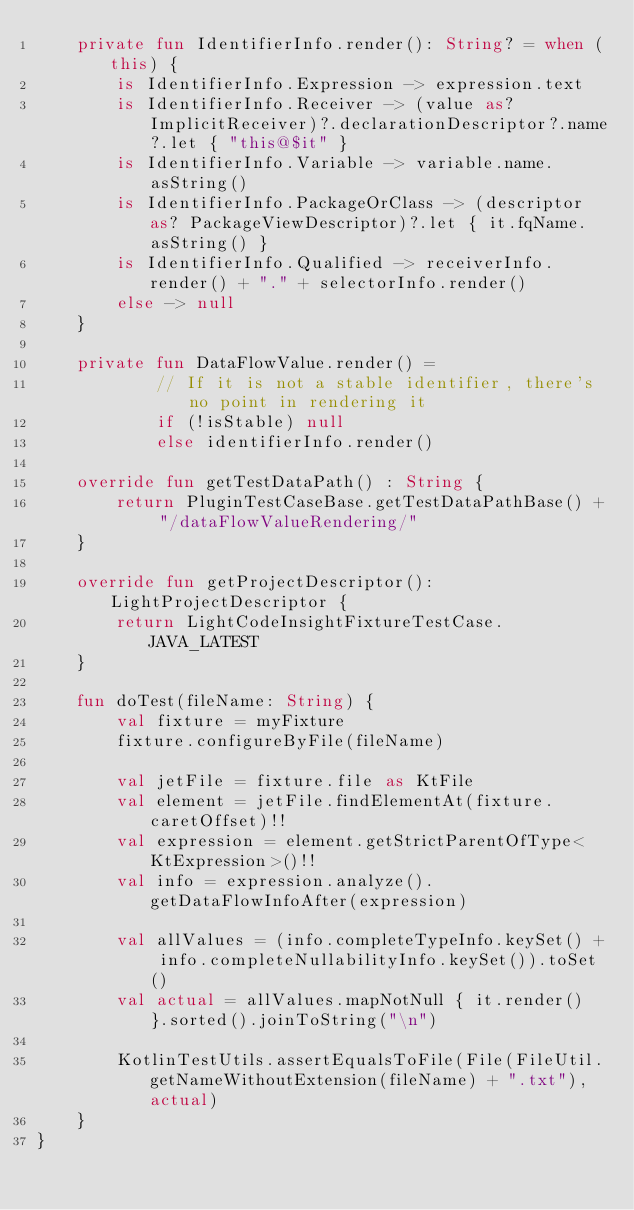Convert code to text. <code><loc_0><loc_0><loc_500><loc_500><_Kotlin_>    private fun IdentifierInfo.render(): String? = when (this) {
        is IdentifierInfo.Expression -> expression.text
        is IdentifierInfo.Receiver -> (value as? ImplicitReceiver)?.declarationDescriptor?.name?.let { "this@$it" }
        is IdentifierInfo.Variable -> variable.name.asString()
        is IdentifierInfo.PackageOrClass -> (descriptor as? PackageViewDescriptor)?.let { it.fqName.asString() }
        is IdentifierInfo.Qualified -> receiverInfo.render() + "." + selectorInfo.render()
        else -> null
    }

    private fun DataFlowValue.render() =
            // If it is not a stable identifier, there's no point in rendering it
            if (!isStable) null
            else identifierInfo.render()

    override fun getTestDataPath() : String {
        return PluginTestCaseBase.getTestDataPathBase() + "/dataFlowValueRendering/"
    }

    override fun getProjectDescriptor(): LightProjectDescriptor {
        return LightCodeInsightFixtureTestCase.JAVA_LATEST
    }

    fun doTest(fileName: String) {
        val fixture = myFixture
        fixture.configureByFile(fileName)

        val jetFile = fixture.file as KtFile
        val element = jetFile.findElementAt(fixture.caretOffset)!!
        val expression = element.getStrictParentOfType<KtExpression>()!!
        val info = expression.analyze().getDataFlowInfoAfter(expression)

        val allValues = (info.completeTypeInfo.keySet() + info.completeNullabilityInfo.keySet()).toSet()
        val actual = allValues.mapNotNull { it.render() }.sorted().joinToString("\n")

        KotlinTestUtils.assertEqualsToFile(File(FileUtil.getNameWithoutExtension(fileName) + ".txt"), actual)
    }
}
</code> 